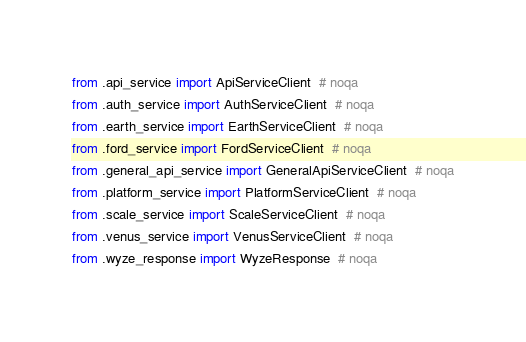Convert code to text. <code><loc_0><loc_0><loc_500><loc_500><_Python_>from .api_service import ApiServiceClient  # noqa
from .auth_service import AuthServiceClient  # noqa
from .earth_service import EarthServiceClient  # noqa
from .ford_service import FordServiceClient  # noqa
from .general_api_service import GeneralApiServiceClient  # noqa
from .platform_service import PlatformServiceClient  # noqa
from .scale_service import ScaleServiceClient  # noqa
from .venus_service import VenusServiceClient  # noqa
from .wyze_response import WyzeResponse  # noqa
</code> 